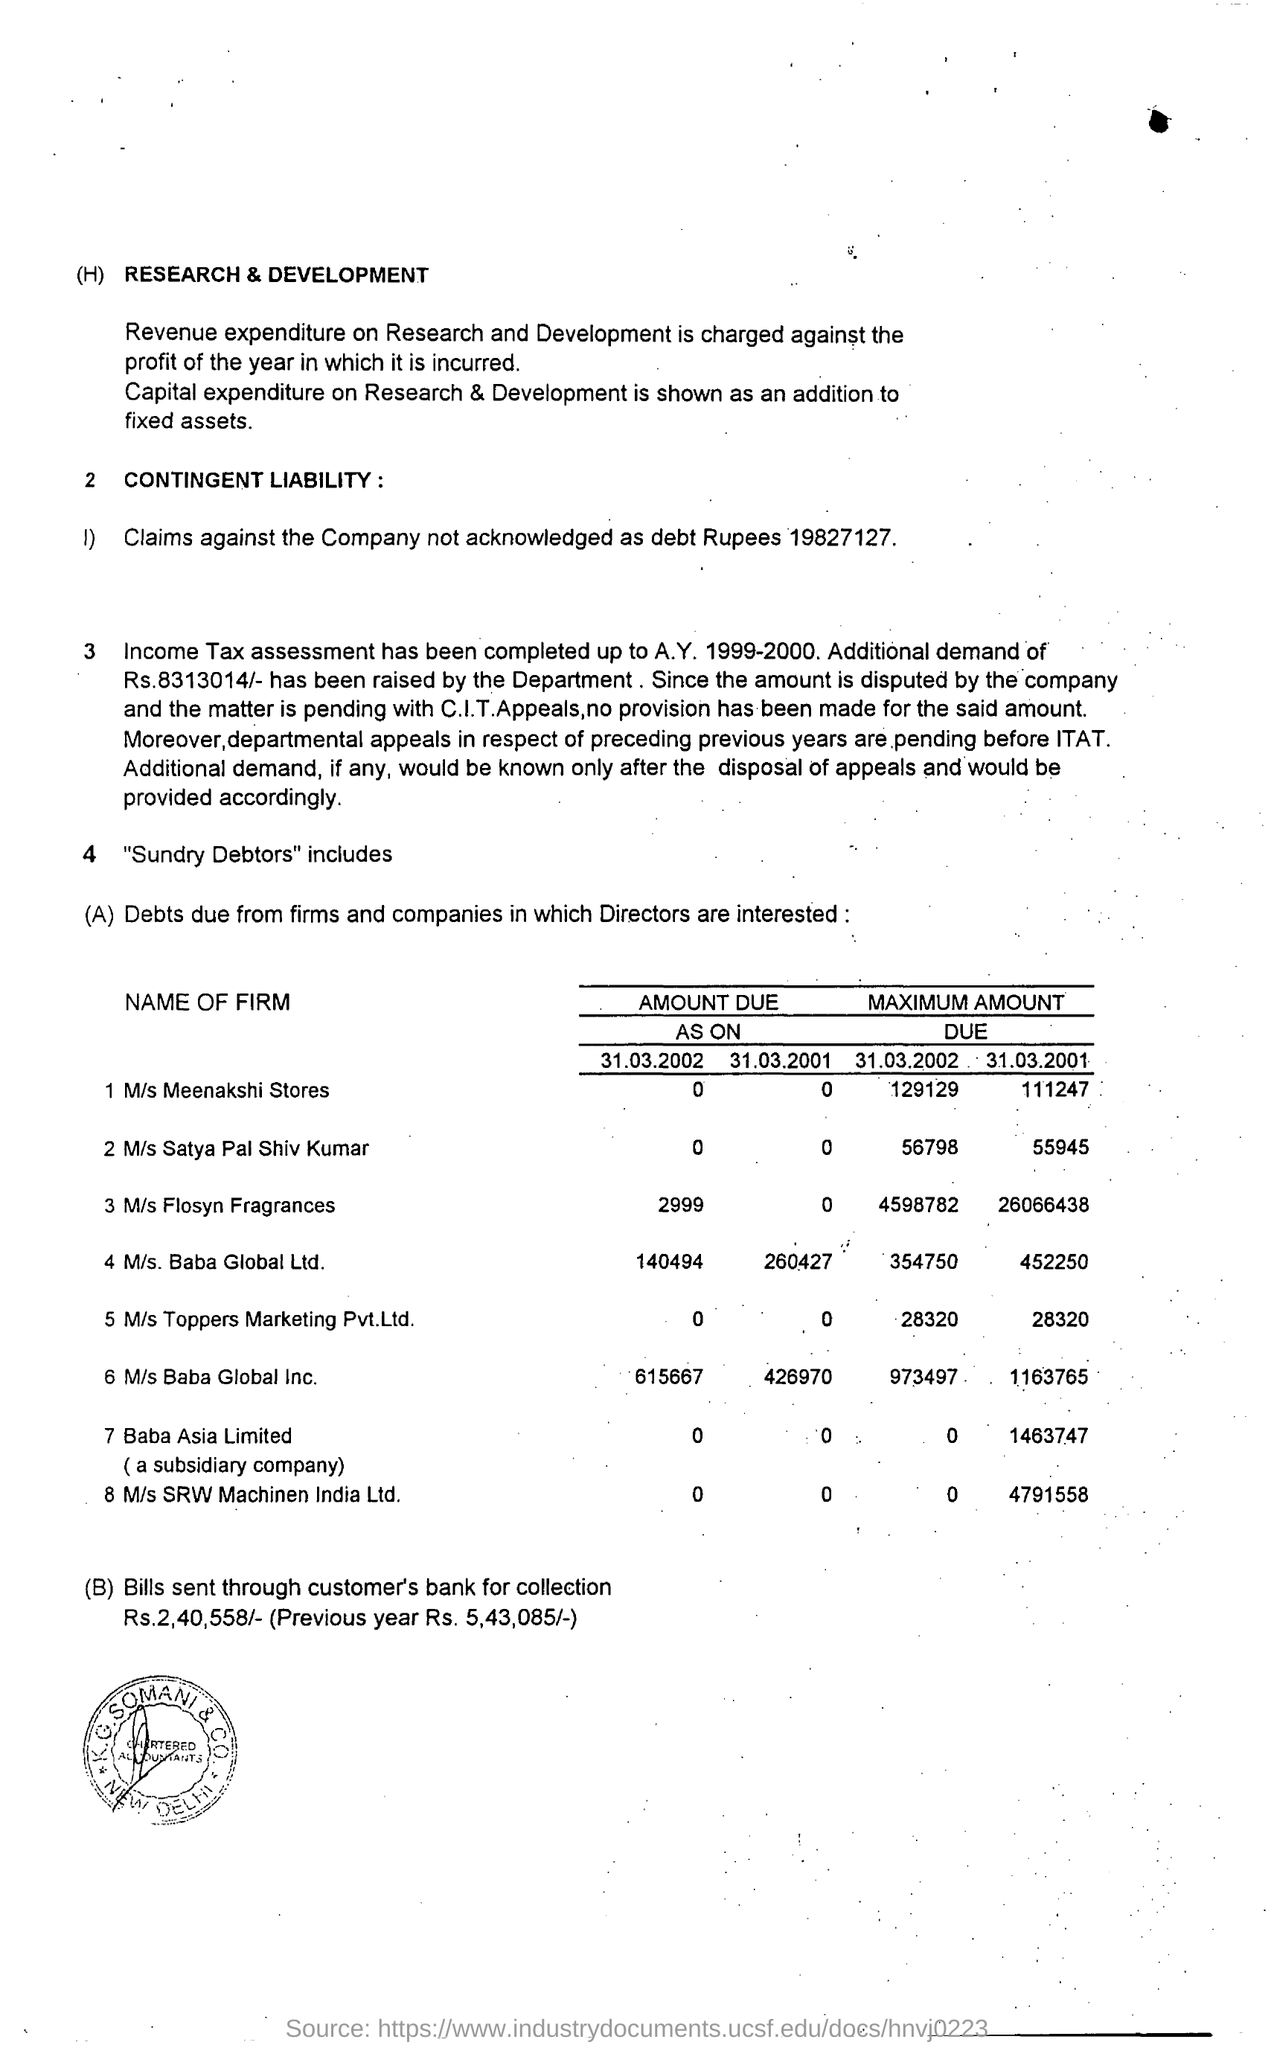Outline some significant characteristics in this image. As of March 31, 2002, the amount due for M/s Baba Global Ltd firm was 140,494. The first firm mentioned is M/s Meenakshi Stores... The maximum amount due for M/s Baba Global Ltd as of March 31, 2001, is 452,250. As of March 31st, 2001, the amount due for M/s Baba Global Ltd firm is 260,427. The Income Tax assessment was completed up to the financial year 1999-2000. 